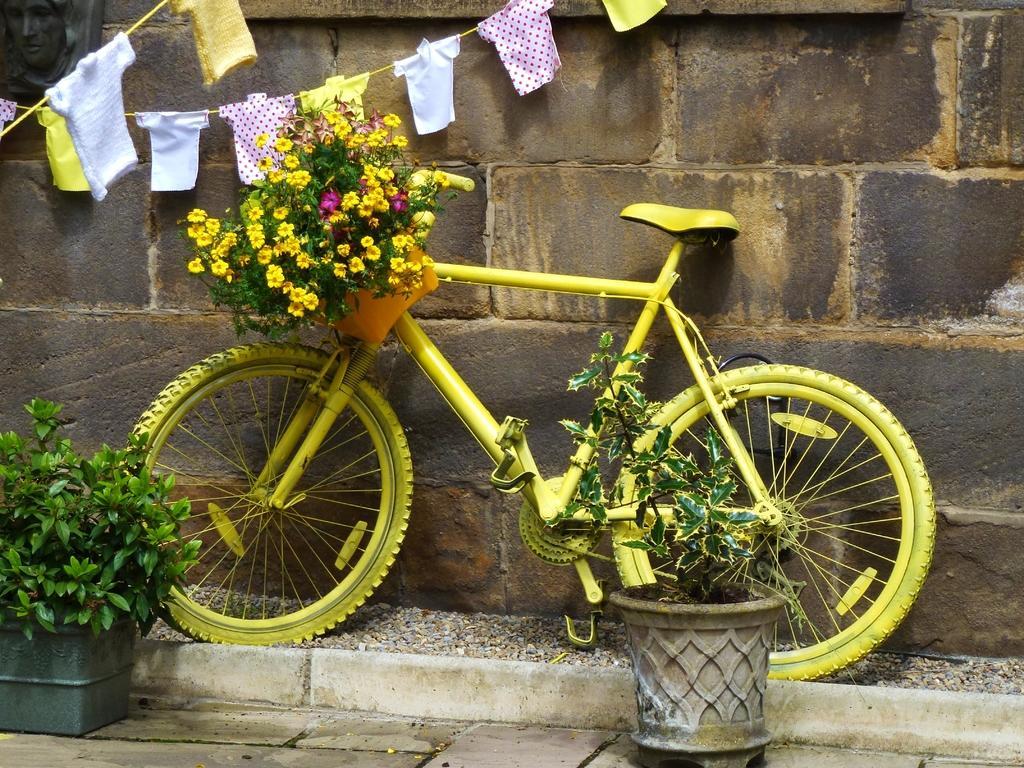Can you describe this image briefly? In this image there is a yellow color bicycle with a basket of flowers in it , and there are plants, clothes on the ropes, wall. 